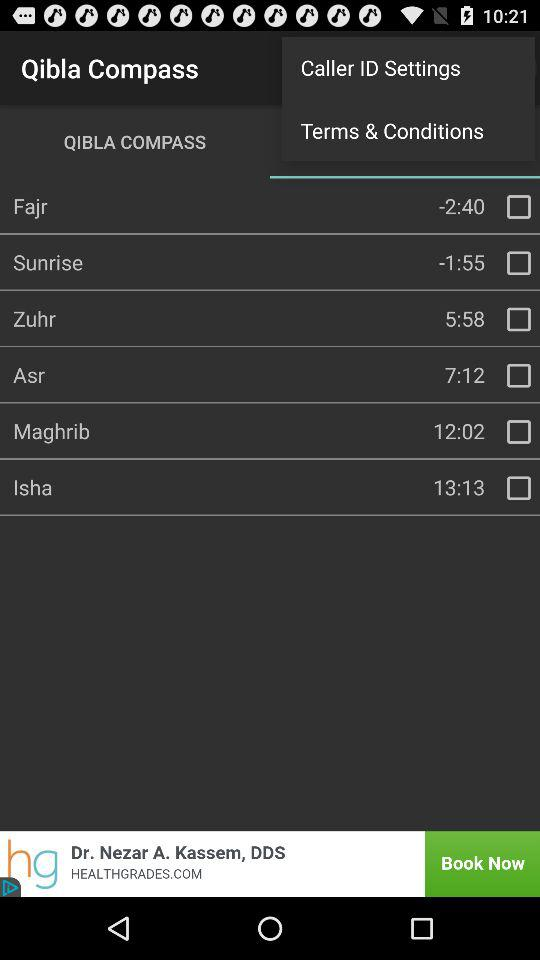What is the current status of "Isha"? The current status of "Isha" is "off". 